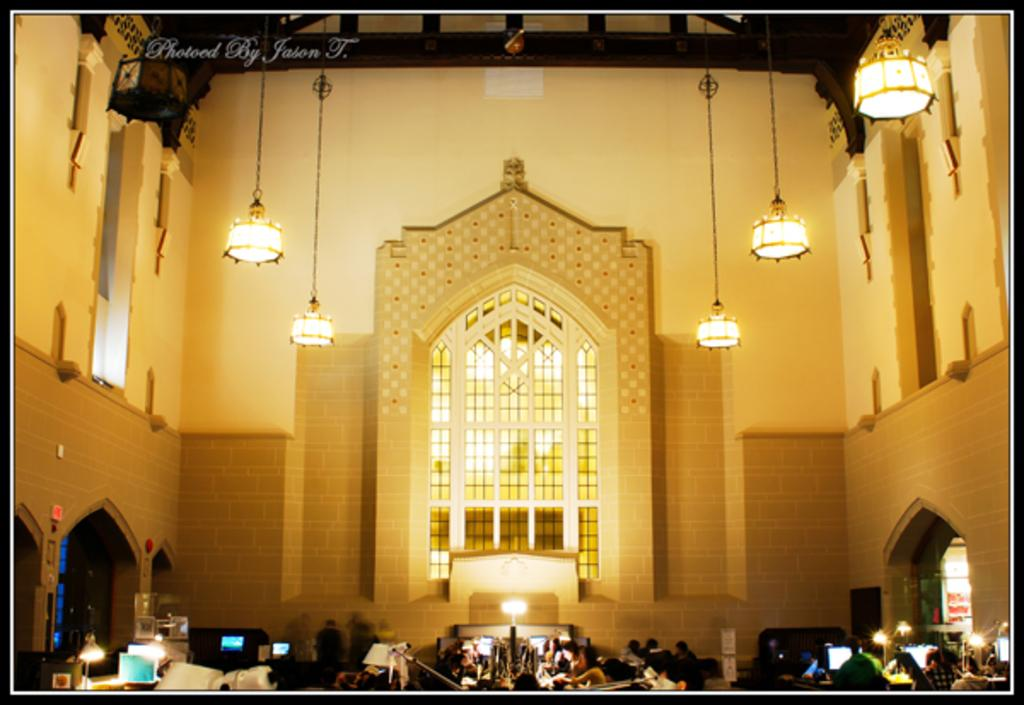Who or what can be seen in the image? There are people in the image. What else is present in the image besides people? There are electronic devices and lights in the image. Can you describe the type of lights in the image? There are hanging lights in the image. What type of railway is visible in the image? There is no railway present in the image. Can you describe the bath that is visible in the image? There is no bath present in the image. 